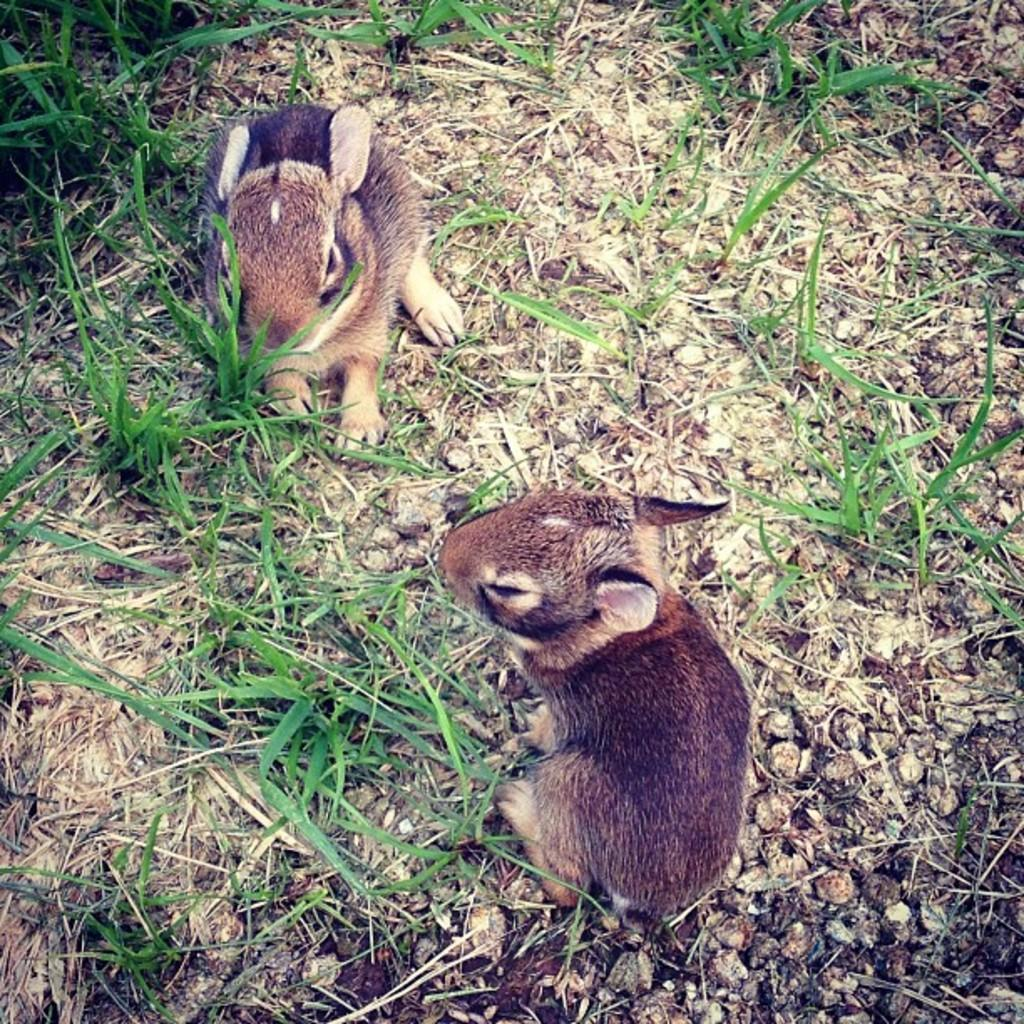What is located in the center of the image? There are two animals in the center of the image. What type of environment is depicted in the background of the image? There is grass in the background of the image. What else can be seen in the background of the image? There is some scrap visible in the background of the image. What type of yam can be seen hanging from the trees in the image? There are no trees or yams present in the image; it features two animals and a grassy background with some scrap. 